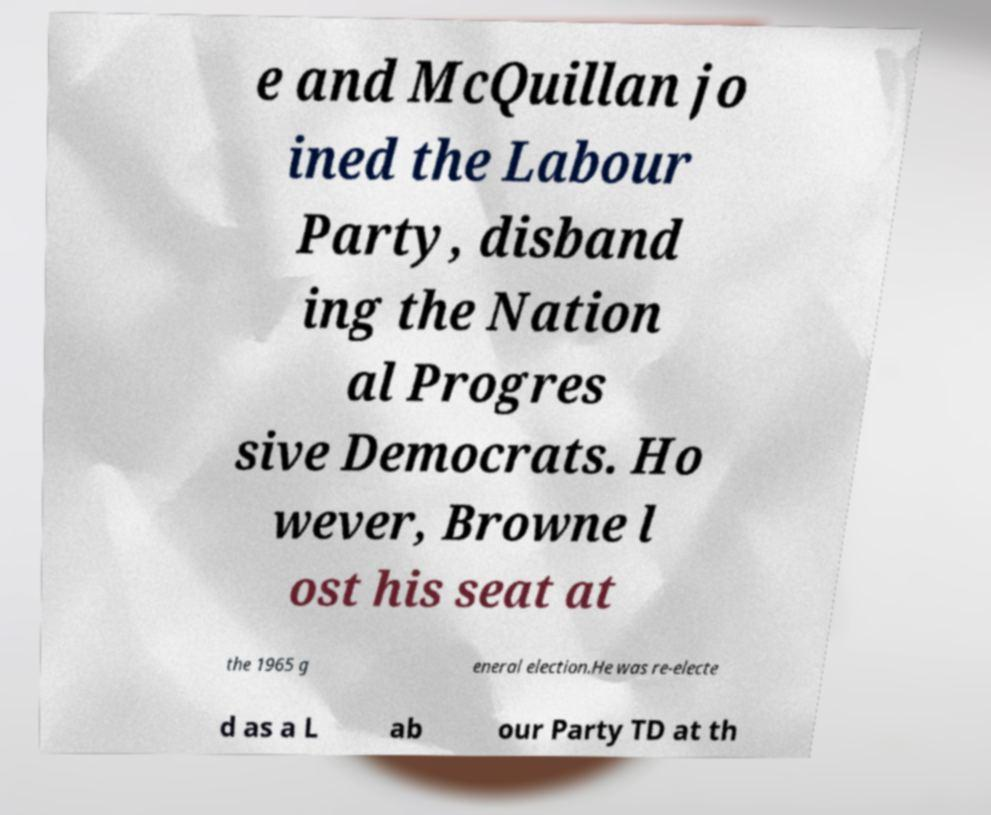Can you read and provide the text displayed in the image?This photo seems to have some interesting text. Can you extract and type it out for me? e and McQuillan jo ined the Labour Party, disband ing the Nation al Progres sive Democrats. Ho wever, Browne l ost his seat at the 1965 g eneral election.He was re-electe d as a L ab our Party TD at th 